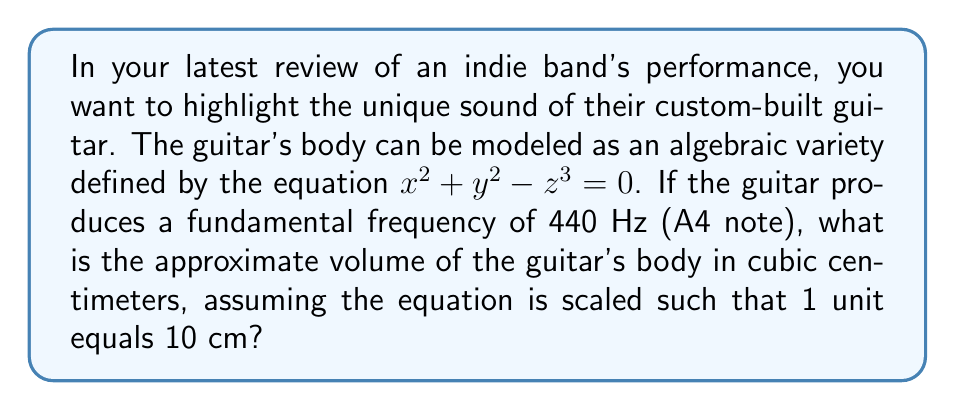Give your solution to this math problem. Let's approach this step-by-step:

1) The equation $x^2 + y^2 - z^3 = 0$ defines a surface in 3D space. This is our algebraic variety representing the guitar's body shape.

2) To find the volume, we need to integrate over the region enclosed by this surface. The volume V is given by the triple integral:

   $$V = \iiint_{R} dxdydz$$

   where R is the region enclosed by the surface.

3) Due to the symmetry of the equation, it's easier to use cylindrical coordinates $(r, \theta, z)$. The transformation is:
   
   $x = r\cos\theta$
   $y = r\sin\theta$
   $z = z$

4) Substituting into our original equation:

   $$(r\cos\theta)^2 + (r\sin\theta)^2 - z^3 = 0$$
   $$r^2 - z^3 = 0$$
   $$r^2 = z^3$$
   $$r = z^{3/2}$$

5) In cylindrical coordinates, the volume integral becomes:

   $$V = \int_{0}^{2\pi} \int_{0}^{z_{max}} \int_{0}^{z^{3/2}} r dr dz d\theta$$

6) The limits for z are from 0 to $z_{max}$, where $z_{max}$ is the maximum height of the guitar body. We can find this by setting $r = 0$ in the original equation:

   $$0 - z^3 = 0$$
   $$z_{max} = 1$$

7) Now we can evaluate the integral:

   $$V = 2\pi \int_{0}^{1} \int_{0}^{z^{3/2}} r dr dz$$
   $$V = 2\pi \int_{0}^{1} \frac{1}{2}z^3 dz$$
   $$V = 2\pi \cdot \frac{1}{8} = \frac{\pi}{4}$$

8) This result is in units^3. Since 1 unit = 10 cm, we need to multiply by 10^3 = 1000 to get cm^3:

   $$V_{cm^3} = \frac{\pi}{4} \cdot 1000 \approx 785.4 cm^3$$
Answer: $785.4 cm^3$ 